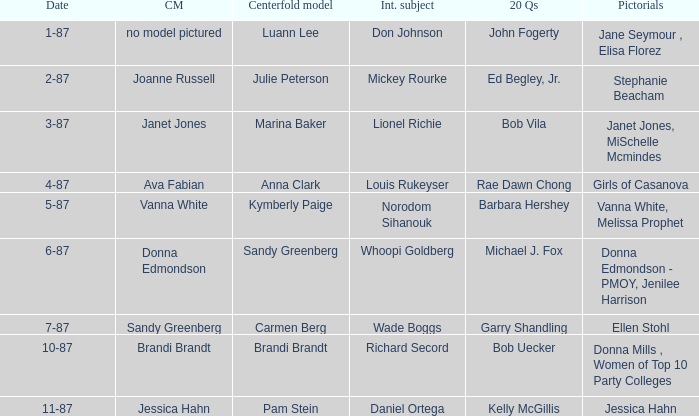Who was the on the cover when Bob Vila did the 20 Questions? Janet Jones. 